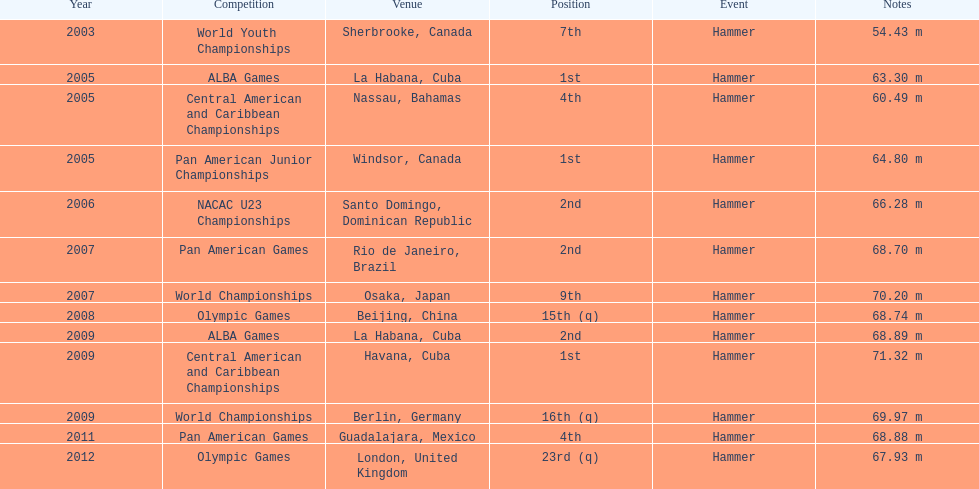In which olympic games did arasay thondike not finish in the top 20? 2012. 